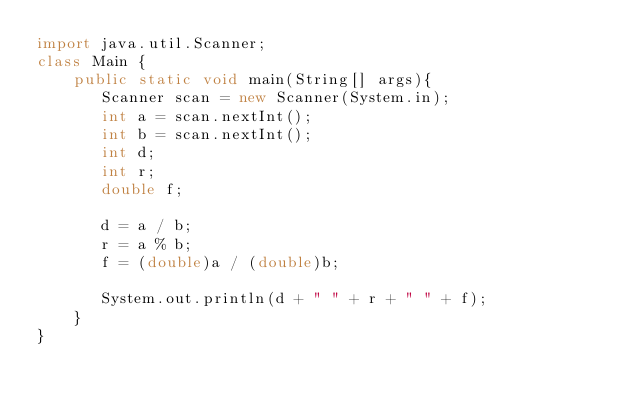<code> <loc_0><loc_0><loc_500><loc_500><_Java_>import java.util.Scanner;
class Main {
    public static void main(String[] args){
       Scanner scan = new Scanner(System.in);
       int a = scan.nextInt();
       int b = scan.nextInt();
       int d;
       int r;
       double f;
       
       d = a / b;
       r = a % b;
       f = (double)a / (double)b;
       
       System.out.println(d + " " + r + " " + f);
    }
}</code> 